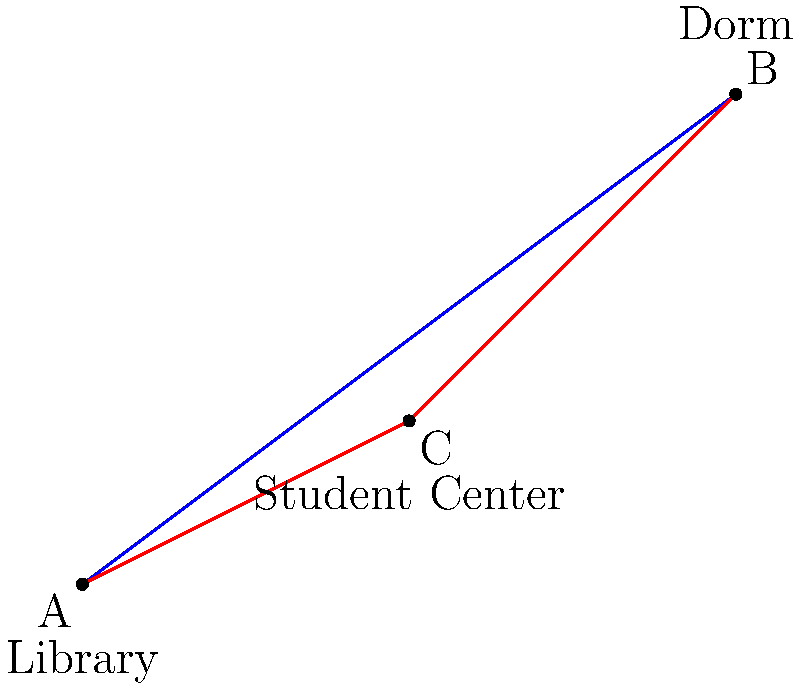On a campus map, the library (point A) is located at (0,0), a dormitory (point B) is at (8,6), and the student center (point C) is at (4,2). A student wants to walk from the library to the dormitory, potentially passing through the student center. Which path is shorter: going directly from A to B, or going from A to C to B? What is the difference in distance between these two paths? Let's solve this step-by-step using vector operations:

1) First, let's calculate the direct path from A to B:
   $\vec{AB} = (8-0, 6-0) = (8,6)$
   Distance AB = $\sqrt{8^2 + 6^2} = \sqrt{100} = 10$ units

2) Now, let's calculate the path through C:
   $\vec{AC} = (4-0, 2-0) = (4,2)$
   Distance AC = $\sqrt{4^2 + 2^2} = \sqrt{20} = 2\sqrt{5}$ units

   $\vec{CB} = (8-4, 6-2) = (4,4)$
   Distance CB = $\sqrt{4^2 + 4^2} = \sqrt{32} = 4\sqrt{2}$ units

3) Total distance ACB = AC + CB = $2\sqrt{5} + 4\sqrt{2}$ units

4) To compare, let's convert this to a decimal:
   $2\sqrt{5} + 4\sqrt{2} \approx 10.47$ units

5) The difference in distance:
   ACB - AB = $10.47 - 10 = 0.47$ units

Therefore, the direct path (AB) is shorter than the path through the student center (ACB).
Answer: The direct path is shorter by approximately 0.47 units. 